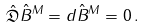Convert formula to latex. <formula><loc_0><loc_0><loc_500><loc_500>\hat { \mathfrak { D } } \hat { B } ^ { M } = d \hat { B } ^ { M } = 0 \, .</formula> 